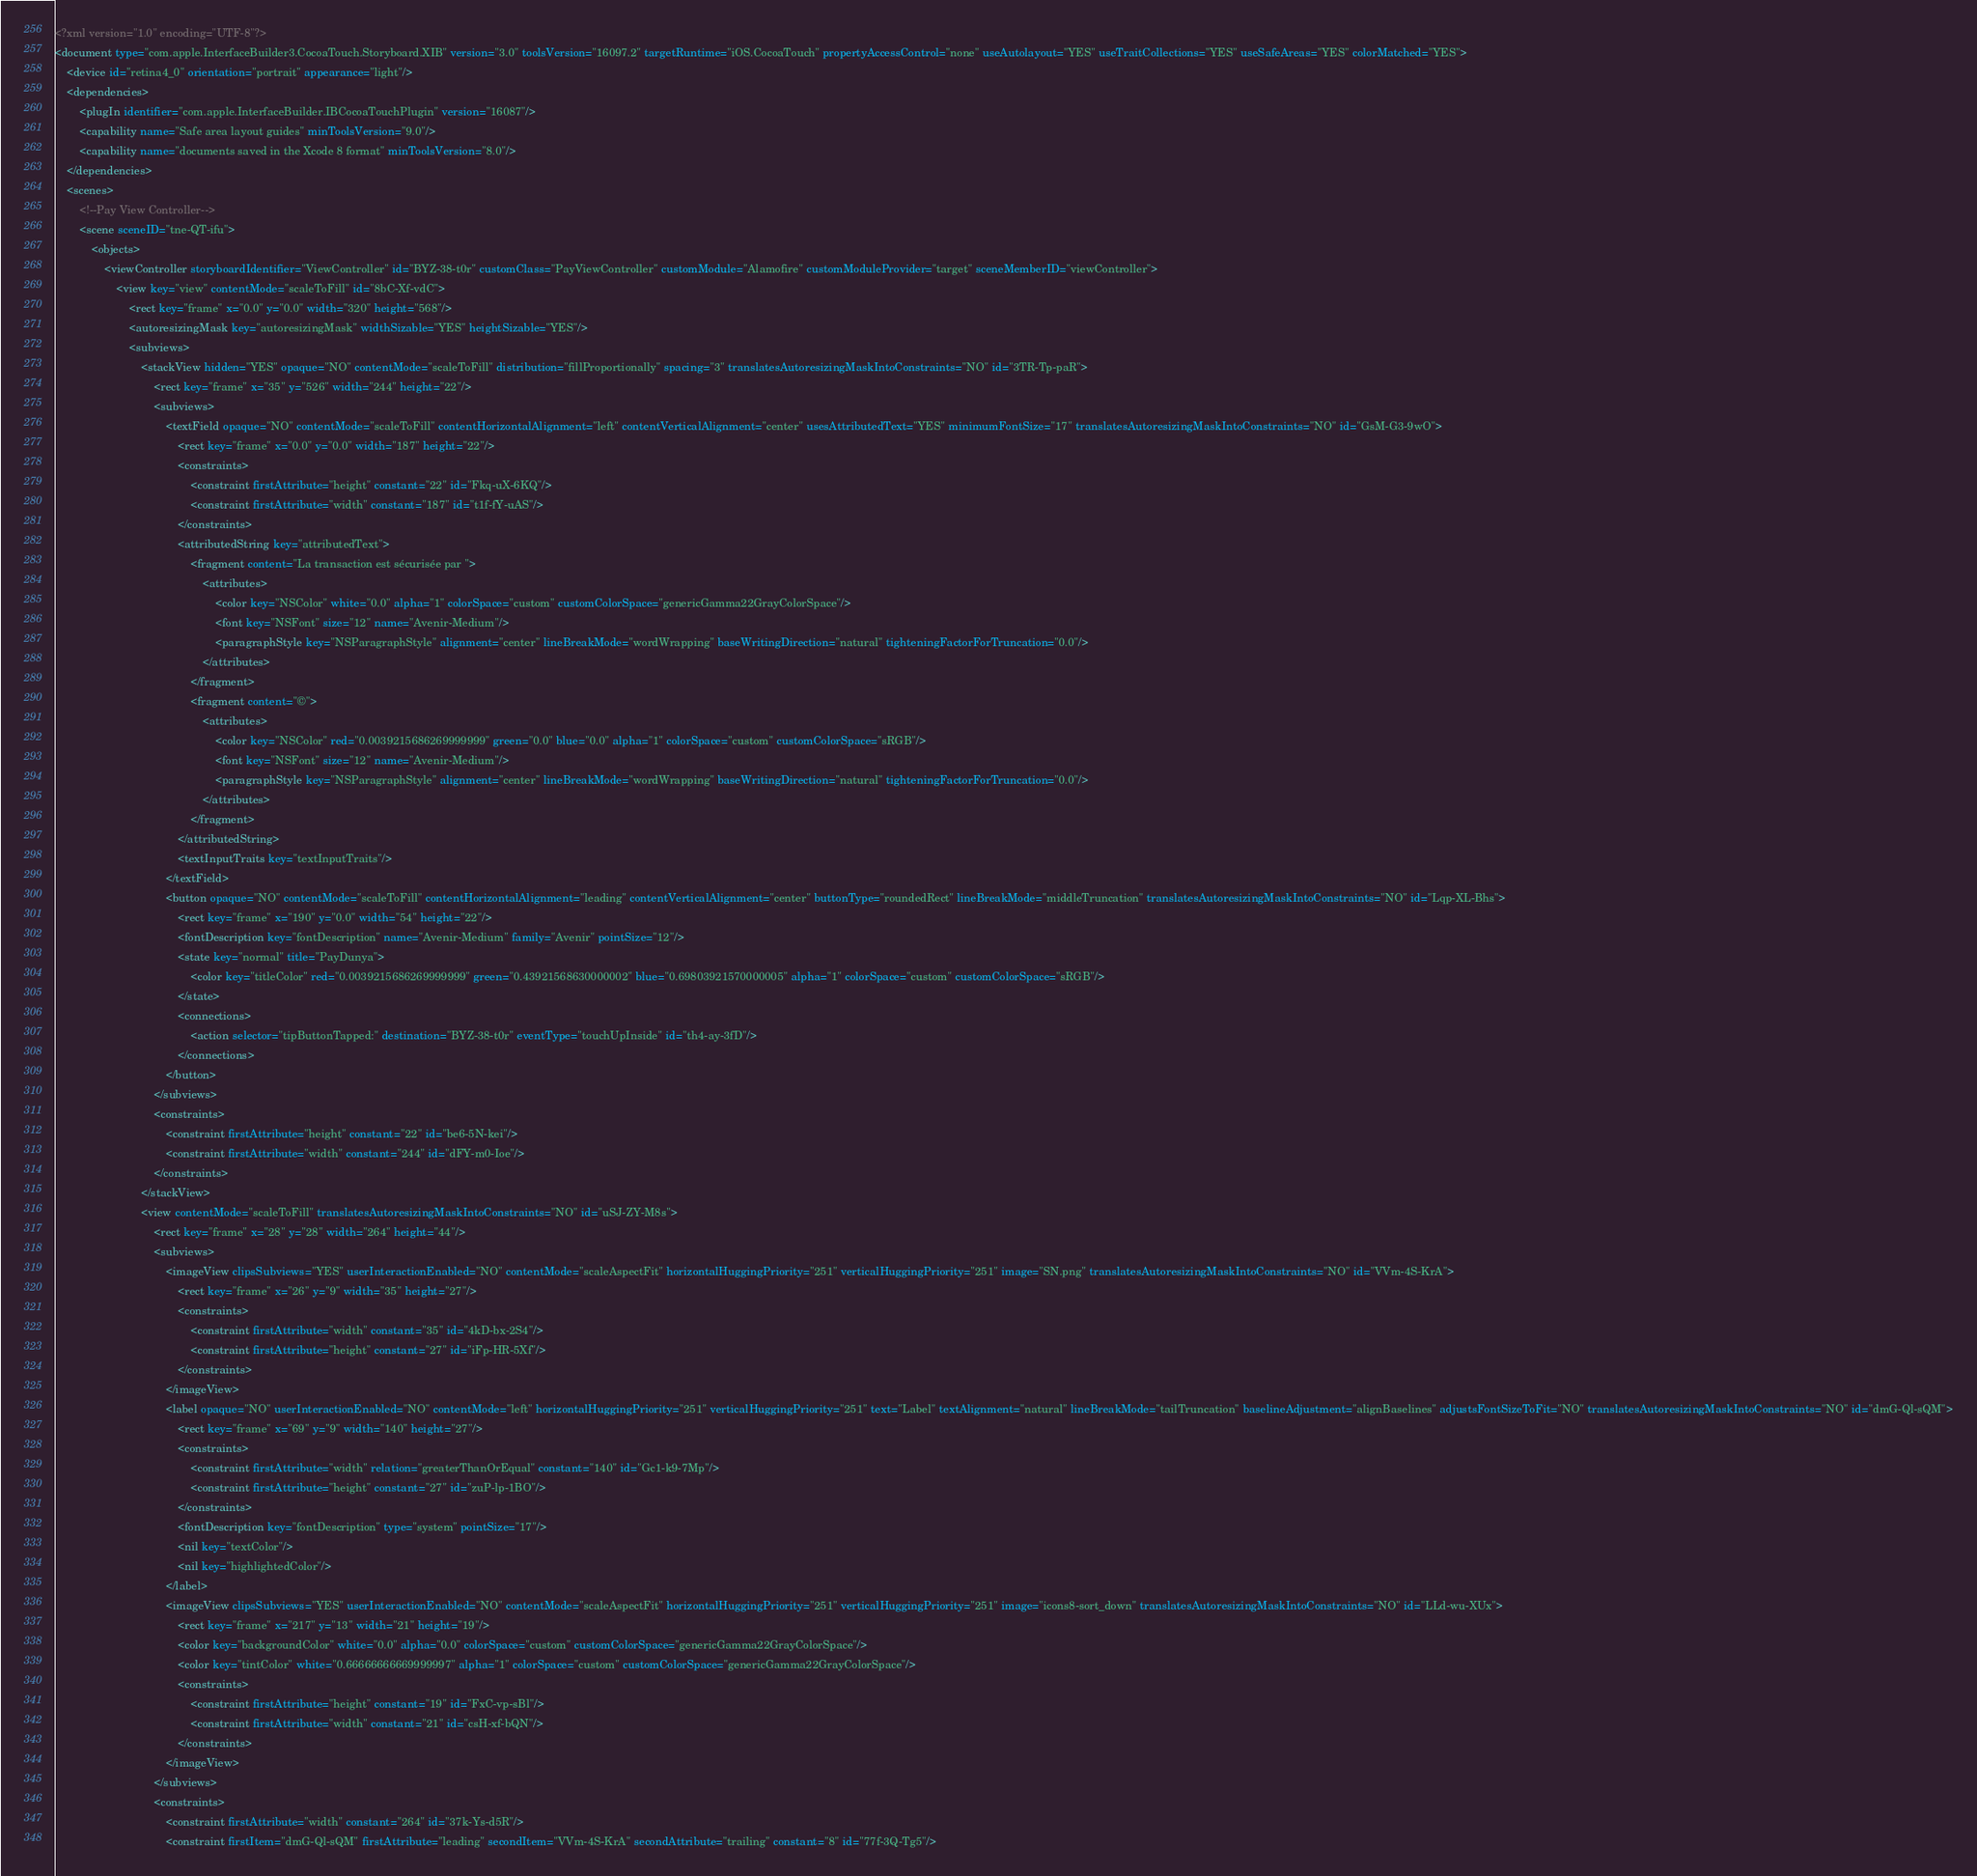<code> <loc_0><loc_0><loc_500><loc_500><_XML_><?xml version="1.0" encoding="UTF-8"?>
<document type="com.apple.InterfaceBuilder3.CocoaTouch.Storyboard.XIB" version="3.0" toolsVersion="16097.2" targetRuntime="iOS.CocoaTouch" propertyAccessControl="none" useAutolayout="YES" useTraitCollections="YES" useSafeAreas="YES" colorMatched="YES">
    <device id="retina4_0" orientation="portrait" appearance="light"/>
    <dependencies>
        <plugIn identifier="com.apple.InterfaceBuilder.IBCocoaTouchPlugin" version="16087"/>
        <capability name="Safe area layout guides" minToolsVersion="9.0"/>
        <capability name="documents saved in the Xcode 8 format" minToolsVersion="8.0"/>
    </dependencies>
    <scenes>
        <!--Pay View Controller-->
        <scene sceneID="tne-QT-ifu">
            <objects>
                <viewController storyboardIdentifier="ViewController" id="BYZ-38-t0r" customClass="PayViewController" customModule="Alamofire" customModuleProvider="target" sceneMemberID="viewController">
                    <view key="view" contentMode="scaleToFill" id="8bC-Xf-vdC">
                        <rect key="frame" x="0.0" y="0.0" width="320" height="568"/>
                        <autoresizingMask key="autoresizingMask" widthSizable="YES" heightSizable="YES"/>
                        <subviews>
                            <stackView hidden="YES" opaque="NO" contentMode="scaleToFill" distribution="fillProportionally" spacing="3" translatesAutoresizingMaskIntoConstraints="NO" id="3TR-Tp-paR">
                                <rect key="frame" x="35" y="526" width="244" height="22"/>
                                <subviews>
                                    <textField opaque="NO" contentMode="scaleToFill" contentHorizontalAlignment="left" contentVerticalAlignment="center" usesAttributedText="YES" minimumFontSize="17" translatesAutoresizingMaskIntoConstraints="NO" id="GsM-G3-9wO">
                                        <rect key="frame" x="0.0" y="0.0" width="187" height="22"/>
                                        <constraints>
                                            <constraint firstAttribute="height" constant="22" id="Fkq-uX-6KQ"/>
                                            <constraint firstAttribute="width" constant="187" id="t1f-fY-uAS"/>
                                        </constraints>
                                        <attributedString key="attributedText">
                                            <fragment content="La transaction est sécurisée par ">
                                                <attributes>
                                                    <color key="NSColor" white="0.0" alpha="1" colorSpace="custom" customColorSpace="genericGamma22GrayColorSpace"/>
                                                    <font key="NSFont" size="12" name="Avenir-Medium"/>
                                                    <paragraphStyle key="NSParagraphStyle" alignment="center" lineBreakMode="wordWrapping" baseWritingDirection="natural" tighteningFactorForTruncation="0.0"/>
                                                </attributes>
                                            </fragment>
                                            <fragment content="©">
                                                <attributes>
                                                    <color key="NSColor" red="0.0039215686269999999" green="0.0" blue="0.0" alpha="1" colorSpace="custom" customColorSpace="sRGB"/>
                                                    <font key="NSFont" size="12" name="Avenir-Medium"/>
                                                    <paragraphStyle key="NSParagraphStyle" alignment="center" lineBreakMode="wordWrapping" baseWritingDirection="natural" tighteningFactorForTruncation="0.0"/>
                                                </attributes>
                                            </fragment>
                                        </attributedString>
                                        <textInputTraits key="textInputTraits"/>
                                    </textField>
                                    <button opaque="NO" contentMode="scaleToFill" contentHorizontalAlignment="leading" contentVerticalAlignment="center" buttonType="roundedRect" lineBreakMode="middleTruncation" translatesAutoresizingMaskIntoConstraints="NO" id="Lqp-XL-Bhs">
                                        <rect key="frame" x="190" y="0.0" width="54" height="22"/>
                                        <fontDescription key="fontDescription" name="Avenir-Medium" family="Avenir" pointSize="12"/>
                                        <state key="normal" title="PayDunya">
                                            <color key="titleColor" red="0.0039215686269999999" green="0.43921568630000002" blue="0.69803921570000005" alpha="1" colorSpace="custom" customColorSpace="sRGB"/>
                                        </state>
                                        <connections>
                                            <action selector="tipButtonTapped:" destination="BYZ-38-t0r" eventType="touchUpInside" id="th4-ay-3fD"/>
                                        </connections>
                                    </button>
                                </subviews>
                                <constraints>
                                    <constraint firstAttribute="height" constant="22" id="be6-5N-kei"/>
                                    <constraint firstAttribute="width" constant="244" id="dFY-m0-Ioe"/>
                                </constraints>
                            </stackView>
                            <view contentMode="scaleToFill" translatesAutoresizingMaskIntoConstraints="NO" id="uSJ-ZY-M8s">
                                <rect key="frame" x="28" y="28" width="264" height="44"/>
                                <subviews>
                                    <imageView clipsSubviews="YES" userInteractionEnabled="NO" contentMode="scaleAspectFit" horizontalHuggingPriority="251" verticalHuggingPriority="251" image="SN.png" translatesAutoresizingMaskIntoConstraints="NO" id="VVm-4S-KrA">
                                        <rect key="frame" x="26" y="9" width="35" height="27"/>
                                        <constraints>
                                            <constraint firstAttribute="width" constant="35" id="4kD-bx-2S4"/>
                                            <constraint firstAttribute="height" constant="27" id="iFp-HR-5Xf"/>
                                        </constraints>
                                    </imageView>
                                    <label opaque="NO" userInteractionEnabled="NO" contentMode="left" horizontalHuggingPriority="251" verticalHuggingPriority="251" text="Label" textAlignment="natural" lineBreakMode="tailTruncation" baselineAdjustment="alignBaselines" adjustsFontSizeToFit="NO" translatesAutoresizingMaskIntoConstraints="NO" id="dmG-Ql-sQM">
                                        <rect key="frame" x="69" y="9" width="140" height="27"/>
                                        <constraints>
                                            <constraint firstAttribute="width" relation="greaterThanOrEqual" constant="140" id="Gc1-k9-7Mp"/>
                                            <constraint firstAttribute="height" constant="27" id="zuP-lp-1BO"/>
                                        </constraints>
                                        <fontDescription key="fontDescription" type="system" pointSize="17"/>
                                        <nil key="textColor"/>
                                        <nil key="highlightedColor"/>
                                    </label>
                                    <imageView clipsSubviews="YES" userInteractionEnabled="NO" contentMode="scaleAspectFit" horizontalHuggingPriority="251" verticalHuggingPriority="251" image="icons8-sort_down" translatesAutoresizingMaskIntoConstraints="NO" id="LLd-wu-XUx">
                                        <rect key="frame" x="217" y="13" width="21" height="19"/>
                                        <color key="backgroundColor" white="0.0" alpha="0.0" colorSpace="custom" customColorSpace="genericGamma22GrayColorSpace"/>
                                        <color key="tintColor" white="0.66666666669999997" alpha="1" colorSpace="custom" customColorSpace="genericGamma22GrayColorSpace"/>
                                        <constraints>
                                            <constraint firstAttribute="height" constant="19" id="FxC-vp-sBl"/>
                                            <constraint firstAttribute="width" constant="21" id="csH-xf-bQN"/>
                                        </constraints>
                                    </imageView>
                                </subviews>
                                <constraints>
                                    <constraint firstAttribute="width" constant="264" id="37k-Ys-d5R"/>
                                    <constraint firstItem="dmG-Ql-sQM" firstAttribute="leading" secondItem="VVm-4S-KrA" secondAttribute="trailing" constant="8" id="77f-3Q-Tg5"/></code> 